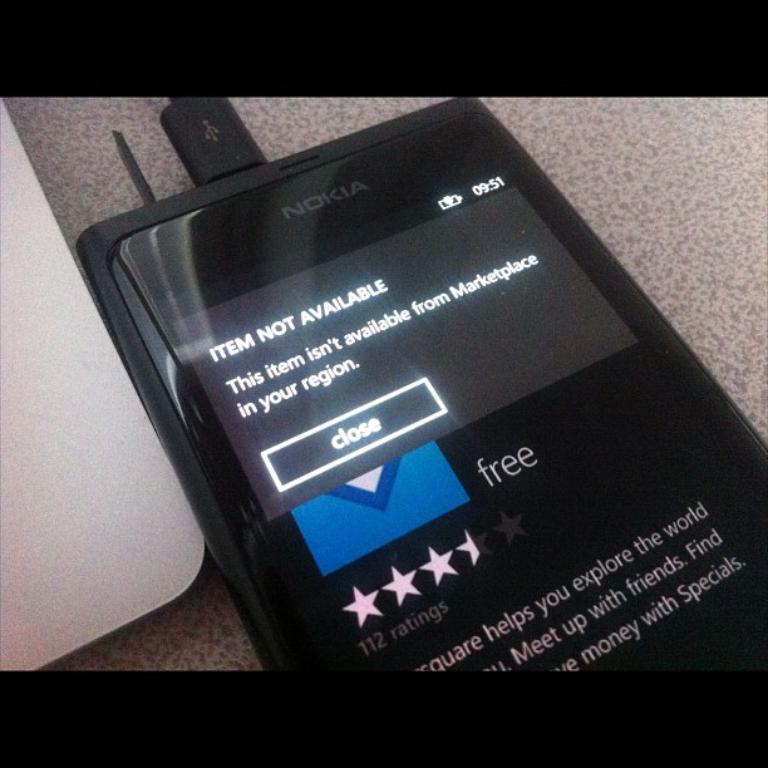How many ratings does this item have?
Offer a terse response. 112. How much is this app?
Offer a terse response. Free. 